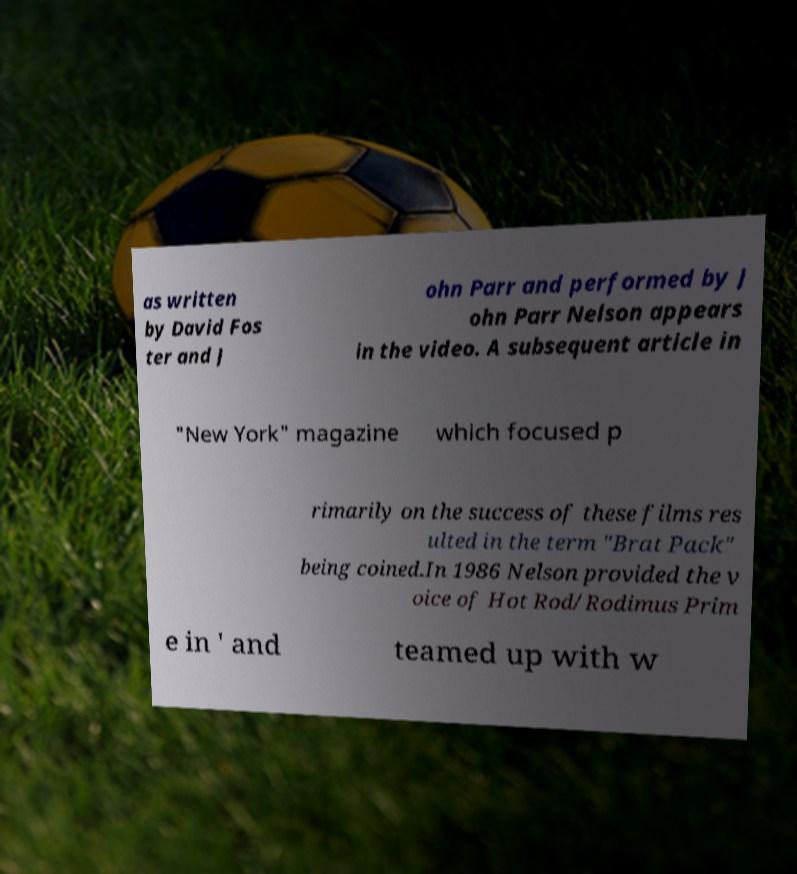Please read and relay the text visible in this image. What does it say? as written by David Fos ter and J ohn Parr and performed by J ohn Parr Nelson appears in the video. A subsequent article in "New York" magazine which focused p rimarily on the success of these films res ulted in the term "Brat Pack" being coined.In 1986 Nelson provided the v oice of Hot Rod/Rodimus Prim e in ' and teamed up with w 